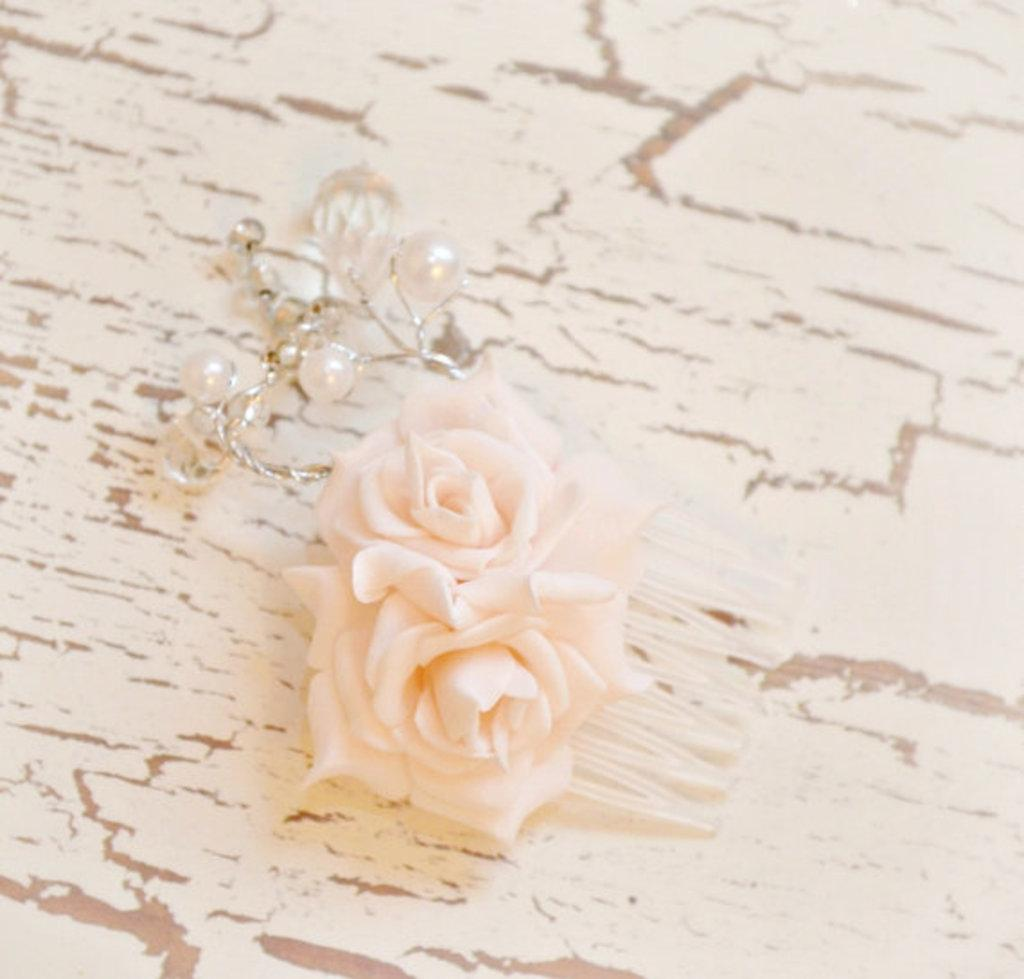What type of decorative items are present in the image? There are artificial flowers and an ornament in the image. Where are these decorative items placed in the image? Both the flowers and the ornament are kept on the floor. How many times has the design of the ornament been folded in the image? The design of the ornament cannot be folded, as it is not a piece of fabric or paper. 